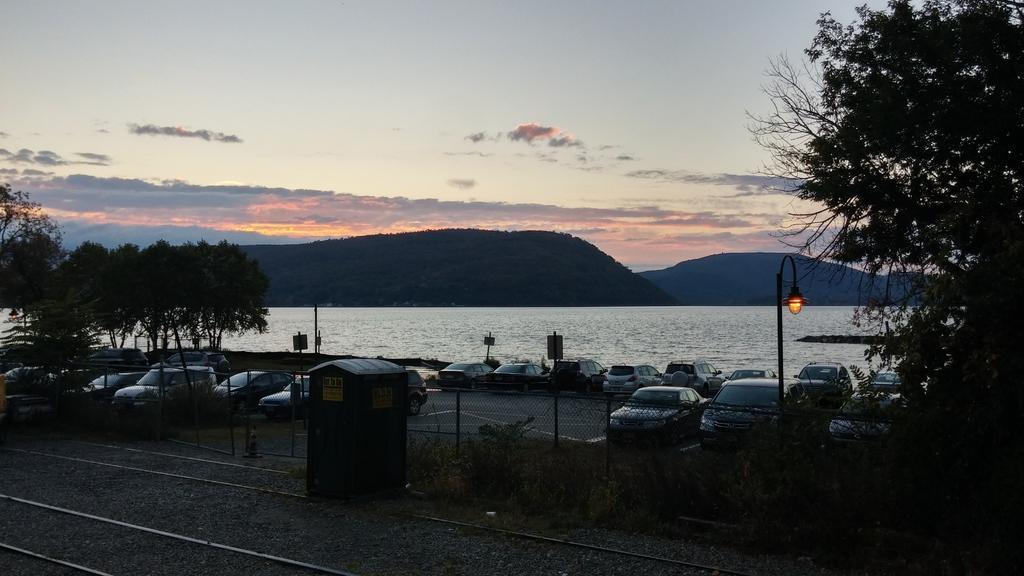Describe this image in one or two sentences. In the foreground I can see tracks, concretes, metal box, grass, plants, fence, trees, light poles and fleets of vehicles on the road. In the background I can see water, mountains and the sky. This image is taken may be near the ocean. 